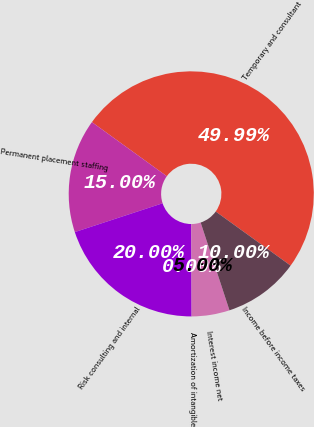Convert chart. <chart><loc_0><loc_0><loc_500><loc_500><pie_chart><fcel>Temporary and consultant<fcel>Permanent placement staffing<fcel>Risk consulting and internal<fcel>Amortization of intangible<fcel>Interest income net<fcel>Income before income taxes<nl><fcel>49.99%<fcel>15.0%<fcel>20.0%<fcel>0.0%<fcel>5.0%<fcel>10.0%<nl></chart> 